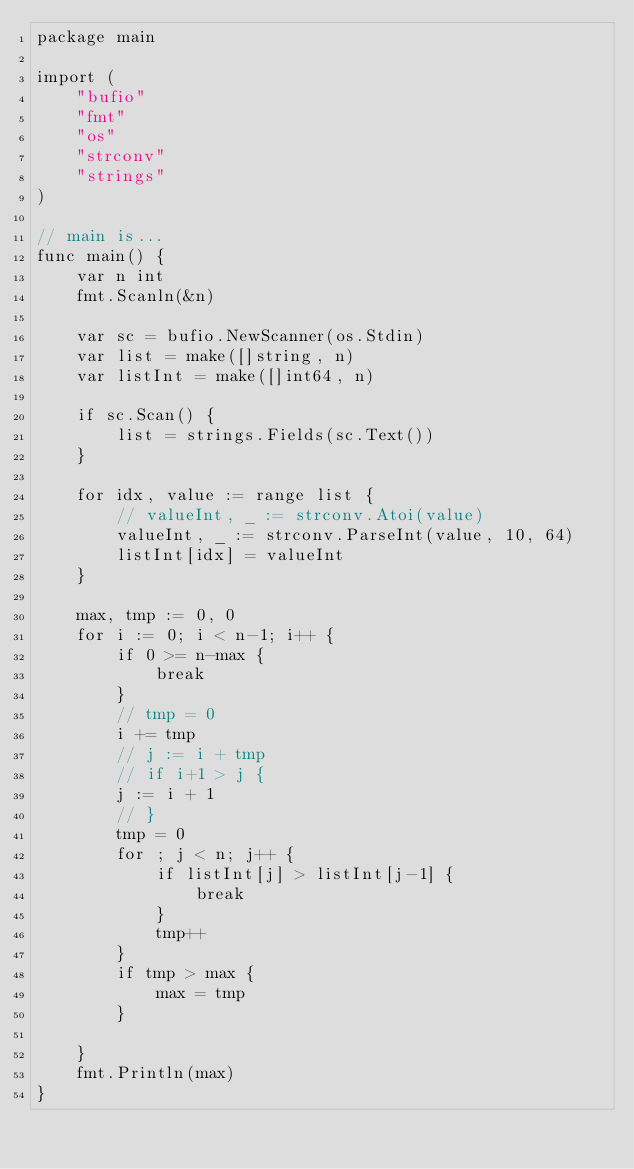Convert code to text. <code><loc_0><loc_0><loc_500><loc_500><_Go_>package main

import (
	"bufio"
	"fmt"
	"os"
	"strconv"
	"strings"
)

// main is...
func main() {
	var n int
	fmt.Scanln(&n)

	var sc = bufio.NewScanner(os.Stdin)
	var list = make([]string, n)
	var listInt = make([]int64, n)

	if sc.Scan() {
		list = strings.Fields(sc.Text())
	}

	for idx, value := range list {
		// valueInt, _ := strconv.Atoi(value)
		valueInt, _ := strconv.ParseInt(value, 10, 64)
		listInt[idx] = valueInt
	}

	max, tmp := 0, 0
	for i := 0; i < n-1; i++ {
		if 0 >= n-max {
			break
		}
		// tmp = 0
		i += tmp
		// j := i + tmp
		// if i+1 > j {
		j := i + 1
		// }
		tmp = 0
		for ; j < n; j++ {
			if listInt[j] > listInt[j-1] {
				break
			}
			tmp++
		}
		if tmp > max {
			max = tmp
		}

	}
	fmt.Println(max)
}

</code> 